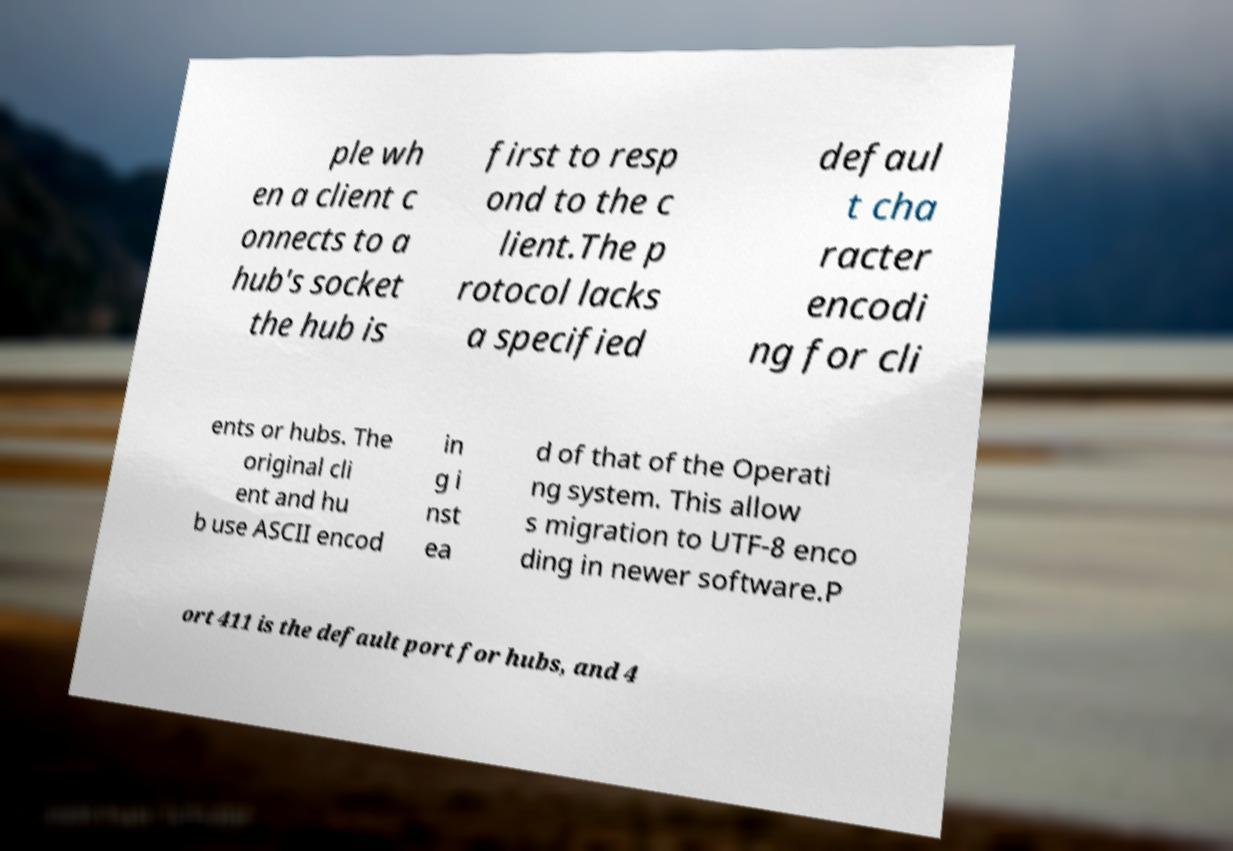What messages or text are displayed in this image? I need them in a readable, typed format. ple wh en a client c onnects to a hub's socket the hub is first to resp ond to the c lient.The p rotocol lacks a specified defaul t cha racter encodi ng for cli ents or hubs. The original cli ent and hu b use ASCII encod in g i nst ea d of that of the Operati ng system. This allow s migration to UTF-8 enco ding in newer software.P ort 411 is the default port for hubs, and 4 